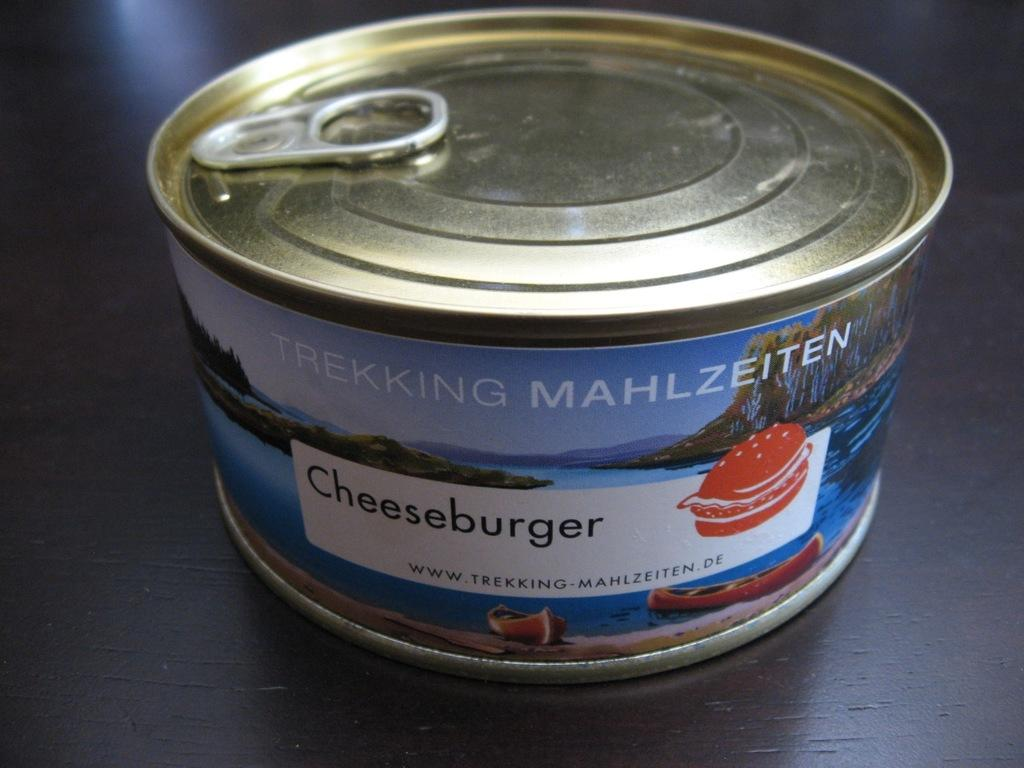Provide a one-sentence caption for the provided image. A can of unopened cheeseburger sits on a dark wooden counter. 